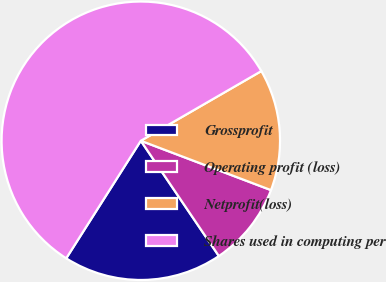Convert chart. <chart><loc_0><loc_0><loc_500><loc_500><pie_chart><fcel>Grossprofit<fcel>Operating profit (loss)<fcel>Netprofit(loss)<fcel>Shares used in computing per<nl><fcel>18.47%<fcel>9.76%<fcel>14.11%<fcel>57.66%<nl></chart> 